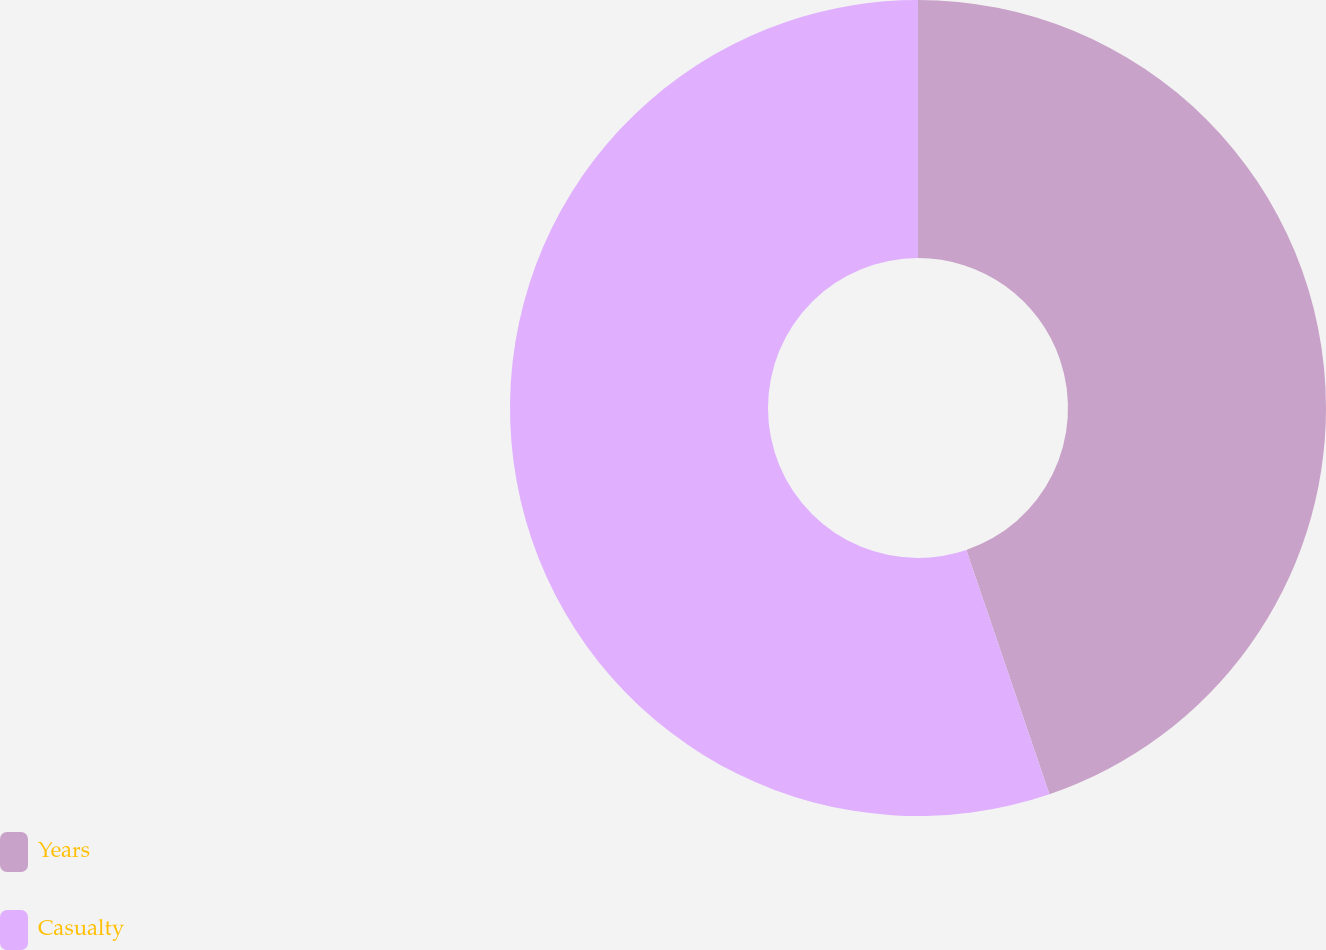Convert chart to OTSL. <chart><loc_0><loc_0><loc_500><loc_500><pie_chart><fcel>Years<fcel>Casualty<nl><fcel>44.78%<fcel>55.22%<nl></chart> 